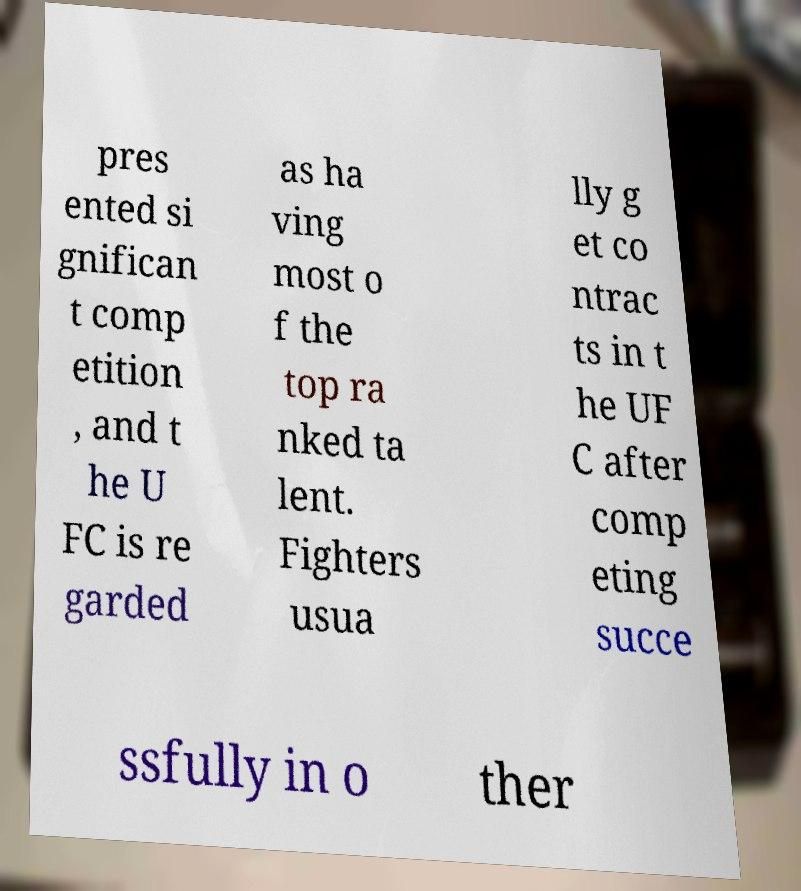What messages or text are displayed in this image? I need them in a readable, typed format. pres ented si gnifican t comp etition , and t he U FC is re garded as ha ving most o f the top ra nked ta lent. Fighters usua lly g et co ntrac ts in t he UF C after comp eting succe ssfully in o ther 